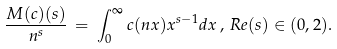Convert formula to latex. <formula><loc_0><loc_0><loc_500><loc_500>\frac { M ( c ) ( s ) } { n ^ { s } } \, = \, \int _ { 0 } ^ { \infty } c ( n x ) x ^ { s - 1 } d x \, , \, R e ( s ) \in ( 0 , 2 ) .</formula> 